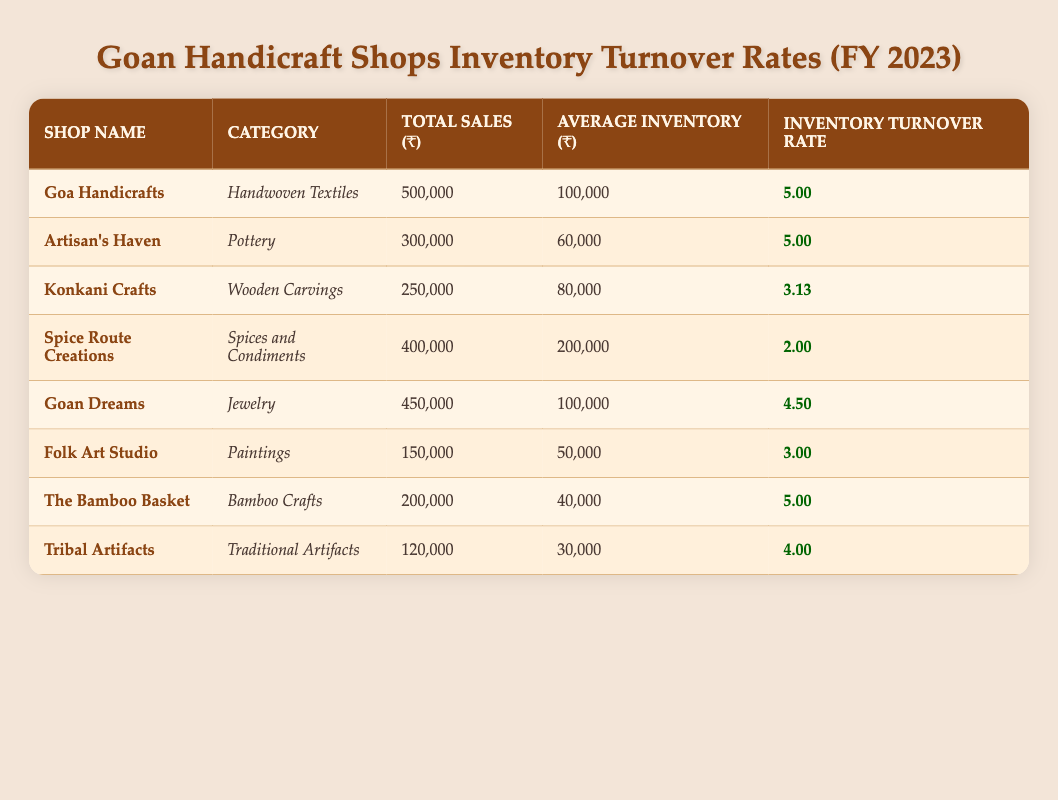What is the total sales for Goa Handicrafts? The table shows that Goa Handicrafts has total sales of ₹500,000.
Answer: 500000 Which shop has the highest inventory turnover rate? Comparing the inventory turnover rates from the table, Goa Handicrafts, Artisan's Haven, and The Bamboo Basket each have a turnover rate of 5, which is the highest.
Answer: Goa Handicrafts, Artisan's Haven, The Bamboo Basket What is the average inventory turnover rate of all shops listed? To find the average, sum up all the inventory turnover rates: 5 + 5 + 3.125 + 2 + 4.5 + 3 + 5 + 4 = 32.625. There are 8 shops, so the average is 32.625 / 8 = 4.078125.
Answer: 4.08 Is the total sales of Spice Route Creations greater than that of Folk Art Studio? The total sales for Spice Route Creations is ₹400,000 and for Folk Art Studio it is ₹150,000. Since ₹400,000 is greater than ₹150,000, the statement is true.
Answer: Yes How much average inventory does The Bamboo Basket have compared to Goan Dreams? The average inventory for The Bamboo Basket is ₹40,000 and for Goan Dreams it is ₹100,000. Since ₹40,000 is less than ₹100,000, The Bamboo Basket has a lower average inventory than Goan Dreams.
Answer: Lower Which category does Artisan's Haven belong to and what is its inventory turnover rate? According to the table, Artisan's Haven belongs to the 'Pottery' category, and its inventory turnover rate is 5.
Answer: Pottery, 5 What is the difference in total sales between Konkani Crafts and Tribal Artifacts? Konkani Crafts has total sales of ₹250,000, and Tribal Artifacts has total sales of ₹120,000. The difference is ₹250,000 - ₹120,000 = ₹130,000.
Answer: 130000 Are there any shops with an inventory turnover rate lower than 3? The shops with inventory turnover rates below 3 are Spice Route Creations (2) and Konkani Crafts (3.125), therefore the answer is yes, as Spice Route Creations is less than 3.
Answer: Yes 